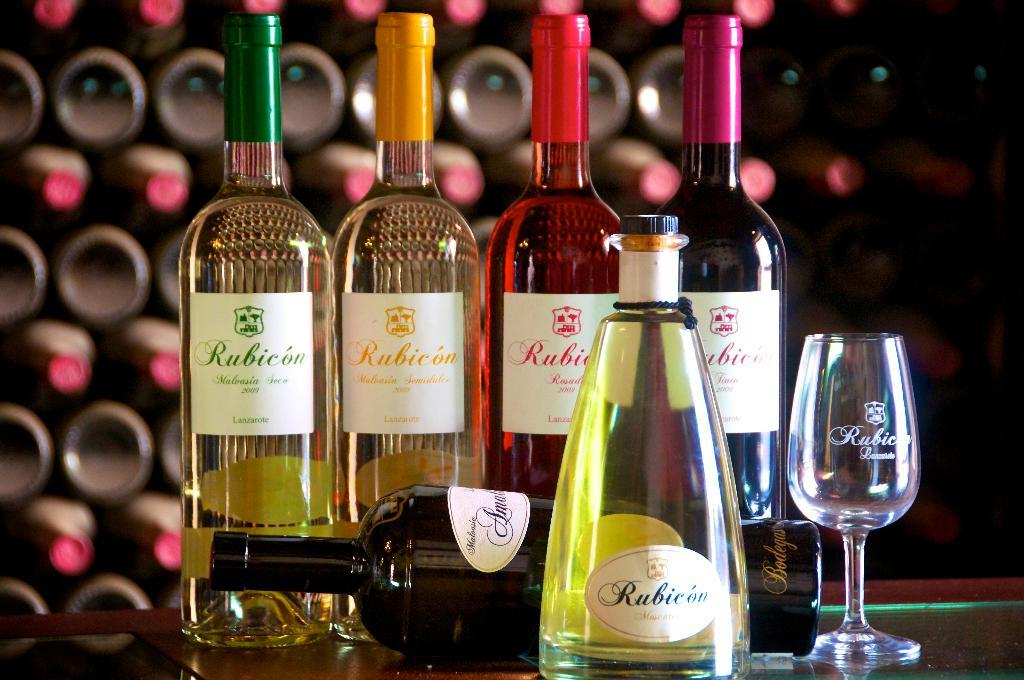<image>
Provide a brief description of the given image. One small wineglass next to five wine bottles from rubicon, four larger ones in back, one pyramidal one in front. 